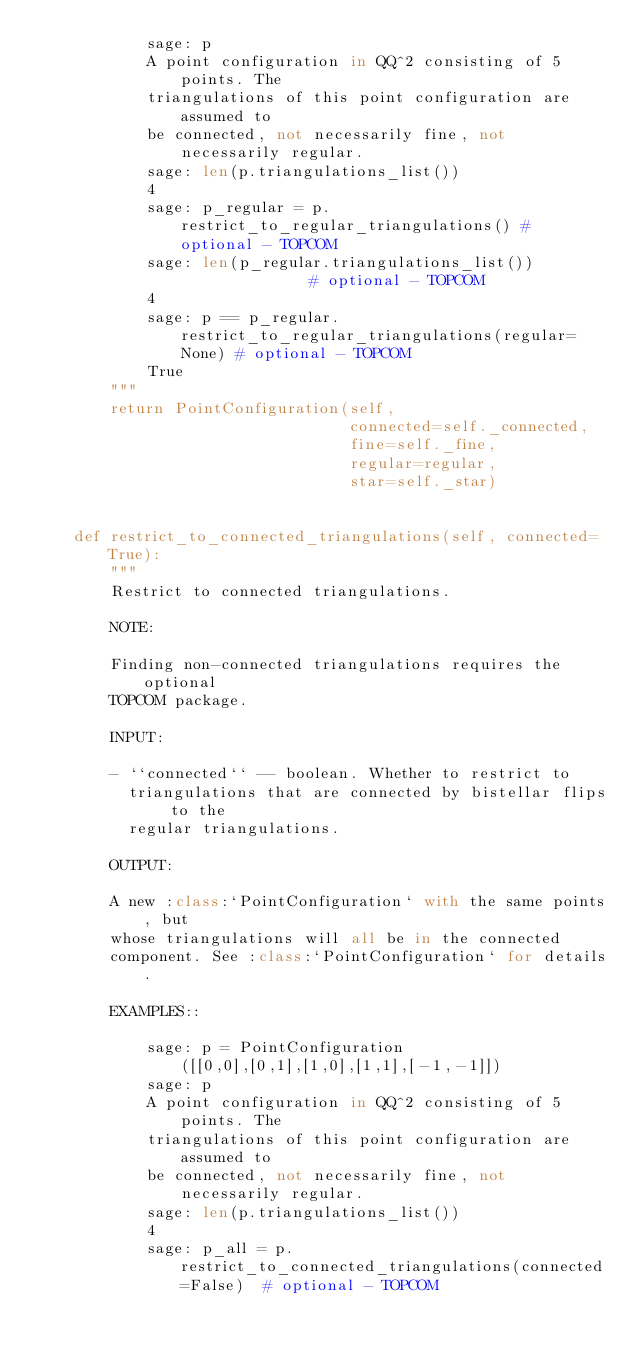Convert code to text. <code><loc_0><loc_0><loc_500><loc_500><_Python_>            sage: p
            A point configuration in QQ^2 consisting of 5 points. The
            triangulations of this point configuration are assumed to
            be connected, not necessarily fine, not necessarily regular.
            sage: len(p.triangulations_list())
            4
            sage: p_regular = p.restrict_to_regular_triangulations() # optional - TOPCOM
            sage: len(p_regular.triangulations_list())               # optional - TOPCOM
            4
            sage: p == p_regular.restrict_to_regular_triangulations(regular=None) # optional - TOPCOM
            True
        """
        return PointConfiguration(self,
                                  connected=self._connected,
                                  fine=self._fine,
                                  regular=regular,
                                  star=self._star)


    def restrict_to_connected_triangulations(self, connected=True):
        """
        Restrict to connected triangulations.

        NOTE:

        Finding non-connected triangulations requires the optional
        TOPCOM package.

        INPUT:

        - ``connected`` -- boolean. Whether to restrict to
          triangulations that are connected by bistellar flips to the
          regular triangulations.

        OUTPUT:

        A new :class:`PointConfiguration` with the same points, but
        whose triangulations will all be in the connected
        component. See :class:`PointConfiguration` for details.

        EXAMPLES::

            sage: p = PointConfiguration([[0,0],[0,1],[1,0],[1,1],[-1,-1]])
            sage: p
            A point configuration in QQ^2 consisting of 5 points. The
            triangulations of this point configuration are assumed to
            be connected, not necessarily fine, not necessarily regular.
            sage: len(p.triangulations_list())
            4
            sage: p_all = p.restrict_to_connected_triangulations(connected=False)  # optional - TOPCOM</code> 